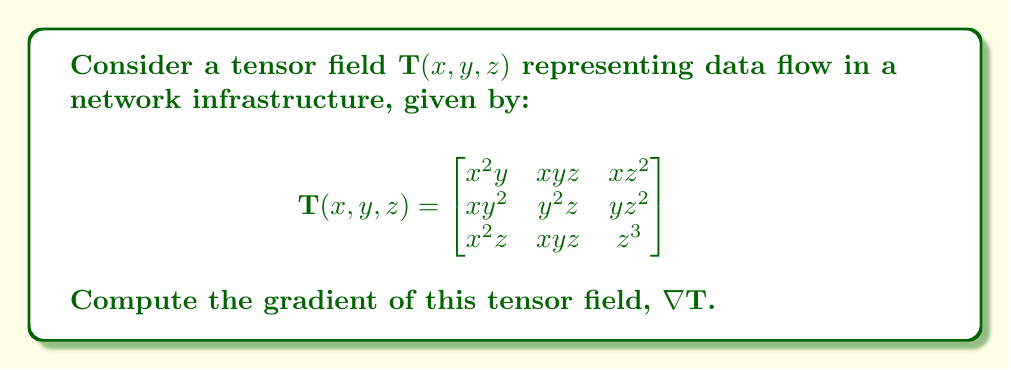Could you help me with this problem? To compute the gradient of the tensor field $\mathbf{T}(x, y, z)$, we need to find the partial derivatives of each component with respect to $x$, $y$, and $z$. The gradient of a tensor field is a third-order tensor.

Step 1: Compute $\frac{\partial \mathbf{T}}{\partial x}$
$$\frac{\partial \mathbf{T}}{\partial x} = \begin{bmatrix}
2xy & yz & z^2 \\
y^2 & 0 & 0 \\
2xz & yz & 0
\end{bmatrix}$$

Step 2: Compute $\frac{\partial \mathbf{T}}{\partial y}$
$$\frac{\partial \mathbf{T}}{\partial y} = \begin{bmatrix}
x^2 & xz & 0 \\
2xy & 2yz & z^2 \\
0 & xz & 0
\end{bmatrix}$$

Step 3: Compute $\frac{\partial \mathbf{T}}{\partial z}$
$$\frac{\partial \mathbf{T}}{\partial z} = \begin{bmatrix}
0 & xy & 2xz \\
0 & y^2 & 2yz \\
x^2 & xy & 3z^2
\end{bmatrix}$$

Step 4: Combine the results to form the gradient tensor
The gradient of $\mathbf{T}$ is a third-order tensor, which can be represented as:

$$\nabla \mathbf{T} = \left[\frac{\partial \mathbf{T}}{\partial x}, \frac{\partial \mathbf{T}}{\partial y}, \frac{\partial \mathbf{T}}{\partial z}\right]$$

This is a 3x3x3 tensor containing all the partial derivatives computed above.
Answer: $$\nabla \mathbf{T} = \left[\begin{bmatrix}
2xy & yz & z^2 \\
y^2 & 0 & 0 \\
2xz & yz & 0
\end{bmatrix}, \begin{bmatrix}
x^2 & xz & 0 \\
2xy & 2yz & z^2 \\
0 & xz & 0
\end{bmatrix}, \begin{bmatrix}
0 & xy & 2xz \\
0 & y^2 & 2yz \\
x^2 & xy & 3z^2
\end{bmatrix}\right]$$ 